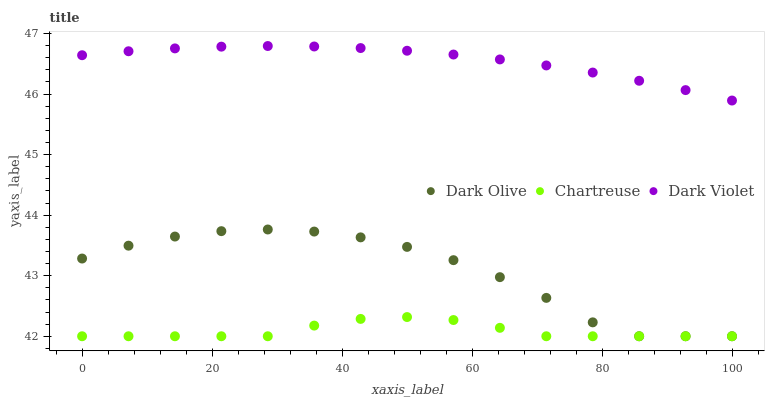Does Chartreuse have the minimum area under the curve?
Answer yes or no. Yes. Does Dark Violet have the maximum area under the curve?
Answer yes or no. Yes. Does Dark Olive have the minimum area under the curve?
Answer yes or no. No. Does Dark Olive have the maximum area under the curve?
Answer yes or no. No. Is Dark Violet the smoothest?
Answer yes or no. Yes. Is Dark Olive the roughest?
Answer yes or no. Yes. Is Dark Olive the smoothest?
Answer yes or no. No. Is Dark Violet the roughest?
Answer yes or no. No. Does Chartreuse have the lowest value?
Answer yes or no. Yes. Does Dark Violet have the lowest value?
Answer yes or no. No. Does Dark Violet have the highest value?
Answer yes or no. Yes. Does Dark Olive have the highest value?
Answer yes or no. No. Is Chartreuse less than Dark Violet?
Answer yes or no. Yes. Is Dark Violet greater than Dark Olive?
Answer yes or no. Yes. Does Chartreuse intersect Dark Olive?
Answer yes or no. Yes. Is Chartreuse less than Dark Olive?
Answer yes or no. No. Is Chartreuse greater than Dark Olive?
Answer yes or no. No. Does Chartreuse intersect Dark Violet?
Answer yes or no. No. 